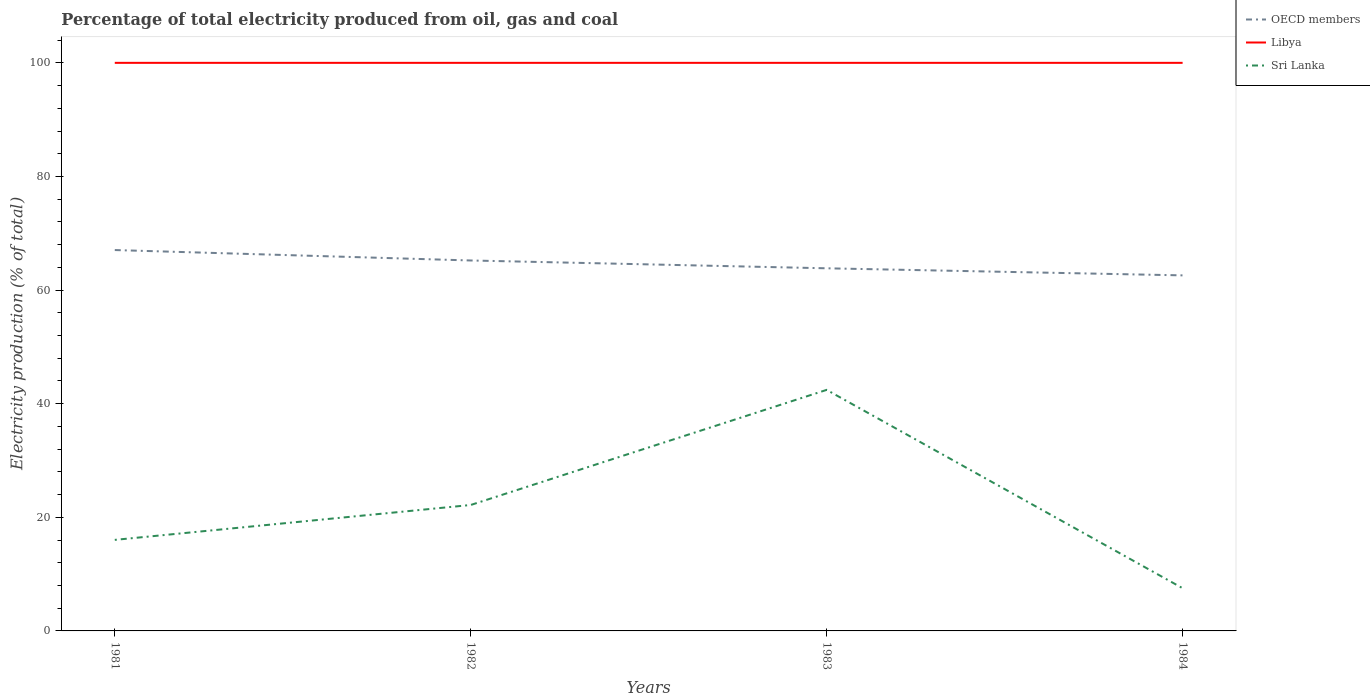Does the line corresponding to OECD members intersect with the line corresponding to Libya?
Give a very brief answer. No. Is the number of lines equal to the number of legend labels?
Your answer should be very brief. Yes. What is the total electricity production in in Sri Lanka in the graph?
Offer a terse response. -6.14. What is the difference between the highest and the second highest electricity production in in Sri Lanka?
Give a very brief answer. 34.91. What is the difference between the highest and the lowest electricity production in in OECD members?
Make the answer very short. 2. Is the electricity production in in Libya strictly greater than the electricity production in in Sri Lanka over the years?
Keep it short and to the point. No. How many lines are there?
Provide a short and direct response. 3. How many years are there in the graph?
Your response must be concise. 4. Does the graph contain grids?
Offer a very short reply. No. How are the legend labels stacked?
Give a very brief answer. Vertical. What is the title of the graph?
Ensure brevity in your answer.  Percentage of total electricity produced from oil, gas and coal. What is the label or title of the Y-axis?
Keep it short and to the point. Electricity production (% of total). What is the Electricity production (% of total) of OECD members in 1981?
Make the answer very short. 67.05. What is the Electricity production (% of total) of Libya in 1981?
Your answer should be compact. 100. What is the Electricity production (% of total) of Sri Lanka in 1981?
Give a very brief answer. 16.03. What is the Electricity production (% of total) in OECD members in 1982?
Ensure brevity in your answer.  65.21. What is the Electricity production (% of total) of Sri Lanka in 1982?
Your answer should be very brief. 22.17. What is the Electricity production (% of total) of OECD members in 1983?
Your response must be concise. 63.83. What is the Electricity production (% of total) in Sri Lanka in 1983?
Provide a short and direct response. 42.43. What is the Electricity production (% of total) in OECD members in 1984?
Your response must be concise. 62.59. What is the Electricity production (% of total) of Sri Lanka in 1984?
Your response must be concise. 7.52. Across all years, what is the maximum Electricity production (% of total) of OECD members?
Give a very brief answer. 67.05. Across all years, what is the maximum Electricity production (% of total) of Sri Lanka?
Give a very brief answer. 42.43. Across all years, what is the minimum Electricity production (% of total) of OECD members?
Your response must be concise. 62.59. Across all years, what is the minimum Electricity production (% of total) of Libya?
Provide a succinct answer. 100. Across all years, what is the minimum Electricity production (% of total) of Sri Lanka?
Make the answer very short. 7.52. What is the total Electricity production (% of total) of OECD members in the graph?
Give a very brief answer. 258.68. What is the total Electricity production (% of total) in Sri Lanka in the graph?
Provide a short and direct response. 88.14. What is the difference between the Electricity production (% of total) of OECD members in 1981 and that in 1982?
Make the answer very short. 1.84. What is the difference between the Electricity production (% of total) of Sri Lanka in 1981 and that in 1982?
Provide a succinct answer. -6.14. What is the difference between the Electricity production (% of total) of OECD members in 1981 and that in 1983?
Your answer should be very brief. 3.21. What is the difference between the Electricity production (% of total) in Libya in 1981 and that in 1983?
Make the answer very short. 0. What is the difference between the Electricity production (% of total) of Sri Lanka in 1981 and that in 1983?
Offer a very short reply. -26.41. What is the difference between the Electricity production (% of total) in OECD members in 1981 and that in 1984?
Provide a short and direct response. 4.46. What is the difference between the Electricity production (% of total) of Sri Lanka in 1981 and that in 1984?
Offer a terse response. 8.51. What is the difference between the Electricity production (% of total) of OECD members in 1982 and that in 1983?
Keep it short and to the point. 1.38. What is the difference between the Electricity production (% of total) of Sri Lanka in 1982 and that in 1983?
Your answer should be compact. -20.26. What is the difference between the Electricity production (% of total) in OECD members in 1982 and that in 1984?
Give a very brief answer. 2.62. What is the difference between the Electricity production (% of total) of Sri Lanka in 1982 and that in 1984?
Keep it short and to the point. 14.65. What is the difference between the Electricity production (% of total) of OECD members in 1983 and that in 1984?
Ensure brevity in your answer.  1.25. What is the difference between the Electricity production (% of total) in Sri Lanka in 1983 and that in 1984?
Your response must be concise. 34.91. What is the difference between the Electricity production (% of total) of OECD members in 1981 and the Electricity production (% of total) of Libya in 1982?
Provide a short and direct response. -32.95. What is the difference between the Electricity production (% of total) in OECD members in 1981 and the Electricity production (% of total) in Sri Lanka in 1982?
Your answer should be compact. 44.88. What is the difference between the Electricity production (% of total) of Libya in 1981 and the Electricity production (% of total) of Sri Lanka in 1982?
Offer a terse response. 77.83. What is the difference between the Electricity production (% of total) of OECD members in 1981 and the Electricity production (% of total) of Libya in 1983?
Provide a succinct answer. -32.95. What is the difference between the Electricity production (% of total) of OECD members in 1981 and the Electricity production (% of total) of Sri Lanka in 1983?
Your response must be concise. 24.61. What is the difference between the Electricity production (% of total) of Libya in 1981 and the Electricity production (% of total) of Sri Lanka in 1983?
Your answer should be compact. 57.57. What is the difference between the Electricity production (% of total) of OECD members in 1981 and the Electricity production (% of total) of Libya in 1984?
Your answer should be very brief. -32.95. What is the difference between the Electricity production (% of total) of OECD members in 1981 and the Electricity production (% of total) of Sri Lanka in 1984?
Ensure brevity in your answer.  59.53. What is the difference between the Electricity production (% of total) in Libya in 1981 and the Electricity production (% of total) in Sri Lanka in 1984?
Provide a succinct answer. 92.48. What is the difference between the Electricity production (% of total) in OECD members in 1982 and the Electricity production (% of total) in Libya in 1983?
Offer a very short reply. -34.79. What is the difference between the Electricity production (% of total) of OECD members in 1982 and the Electricity production (% of total) of Sri Lanka in 1983?
Your answer should be compact. 22.78. What is the difference between the Electricity production (% of total) in Libya in 1982 and the Electricity production (% of total) in Sri Lanka in 1983?
Your answer should be very brief. 57.57. What is the difference between the Electricity production (% of total) in OECD members in 1982 and the Electricity production (% of total) in Libya in 1984?
Give a very brief answer. -34.79. What is the difference between the Electricity production (% of total) in OECD members in 1982 and the Electricity production (% of total) in Sri Lanka in 1984?
Keep it short and to the point. 57.69. What is the difference between the Electricity production (% of total) of Libya in 1982 and the Electricity production (% of total) of Sri Lanka in 1984?
Ensure brevity in your answer.  92.48. What is the difference between the Electricity production (% of total) of OECD members in 1983 and the Electricity production (% of total) of Libya in 1984?
Ensure brevity in your answer.  -36.17. What is the difference between the Electricity production (% of total) of OECD members in 1983 and the Electricity production (% of total) of Sri Lanka in 1984?
Your answer should be very brief. 56.31. What is the difference between the Electricity production (% of total) of Libya in 1983 and the Electricity production (% of total) of Sri Lanka in 1984?
Provide a succinct answer. 92.48. What is the average Electricity production (% of total) in OECD members per year?
Offer a very short reply. 64.67. What is the average Electricity production (% of total) in Sri Lanka per year?
Offer a very short reply. 22.04. In the year 1981, what is the difference between the Electricity production (% of total) in OECD members and Electricity production (% of total) in Libya?
Keep it short and to the point. -32.95. In the year 1981, what is the difference between the Electricity production (% of total) of OECD members and Electricity production (% of total) of Sri Lanka?
Provide a succinct answer. 51.02. In the year 1981, what is the difference between the Electricity production (% of total) in Libya and Electricity production (% of total) in Sri Lanka?
Provide a short and direct response. 83.97. In the year 1982, what is the difference between the Electricity production (% of total) in OECD members and Electricity production (% of total) in Libya?
Provide a short and direct response. -34.79. In the year 1982, what is the difference between the Electricity production (% of total) in OECD members and Electricity production (% of total) in Sri Lanka?
Your answer should be compact. 43.04. In the year 1982, what is the difference between the Electricity production (% of total) of Libya and Electricity production (% of total) of Sri Lanka?
Give a very brief answer. 77.83. In the year 1983, what is the difference between the Electricity production (% of total) in OECD members and Electricity production (% of total) in Libya?
Offer a terse response. -36.17. In the year 1983, what is the difference between the Electricity production (% of total) in OECD members and Electricity production (% of total) in Sri Lanka?
Your answer should be compact. 21.4. In the year 1983, what is the difference between the Electricity production (% of total) in Libya and Electricity production (% of total) in Sri Lanka?
Your answer should be compact. 57.57. In the year 1984, what is the difference between the Electricity production (% of total) of OECD members and Electricity production (% of total) of Libya?
Your answer should be very brief. -37.41. In the year 1984, what is the difference between the Electricity production (% of total) in OECD members and Electricity production (% of total) in Sri Lanka?
Give a very brief answer. 55.07. In the year 1984, what is the difference between the Electricity production (% of total) in Libya and Electricity production (% of total) in Sri Lanka?
Provide a succinct answer. 92.48. What is the ratio of the Electricity production (% of total) of OECD members in 1981 to that in 1982?
Provide a succinct answer. 1.03. What is the ratio of the Electricity production (% of total) of Libya in 1981 to that in 1982?
Your response must be concise. 1. What is the ratio of the Electricity production (% of total) in Sri Lanka in 1981 to that in 1982?
Provide a succinct answer. 0.72. What is the ratio of the Electricity production (% of total) of OECD members in 1981 to that in 1983?
Offer a terse response. 1.05. What is the ratio of the Electricity production (% of total) of Sri Lanka in 1981 to that in 1983?
Give a very brief answer. 0.38. What is the ratio of the Electricity production (% of total) in OECD members in 1981 to that in 1984?
Make the answer very short. 1.07. What is the ratio of the Electricity production (% of total) in Libya in 1981 to that in 1984?
Give a very brief answer. 1. What is the ratio of the Electricity production (% of total) in Sri Lanka in 1981 to that in 1984?
Keep it short and to the point. 2.13. What is the ratio of the Electricity production (% of total) in OECD members in 1982 to that in 1983?
Keep it short and to the point. 1.02. What is the ratio of the Electricity production (% of total) of Libya in 1982 to that in 1983?
Give a very brief answer. 1. What is the ratio of the Electricity production (% of total) of Sri Lanka in 1982 to that in 1983?
Make the answer very short. 0.52. What is the ratio of the Electricity production (% of total) of OECD members in 1982 to that in 1984?
Your answer should be very brief. 1.04. What is the ratio of the Electricity production (% of total) of Libya in 1982 to that in 1984?
Give a very brief answer. 1. What is the ratio of the Electricity production (% of total) of Sri Lanka in 1982 to that in 1984?
Offer a terse response. 2.95. What is the ratio of the Electricity production (% of total) in OECD members in 1983 to that in 1984?
Offer a very short reply. 1.02. What is the ratio of the Electricity production (% of total) in Sri Lanka in 1983 to that in 1984?
Your answer should be compact. 5.64. What is the difference between the highest and the second highest Electricity production (% of total) of OECD members?
Keep it short and to the point. 1.84. What is the difference between the highest and the second highest Electricity production (% of total) of Sri Lanka?
Provide a succinct answer. 20.26. What is the difference between the highest and the lowest Electricity production (% of total) in OECD members?
Give a very brief answer. 4.46. What is the difference between the highest and the lowest Electricity production (% of total) in Libya?
Provide a succinct answer. 0. What is the difference between the highest and the lowest Electricity production (% of total) in Sri Lanka?
Your answer should be very brief. 34.91. 